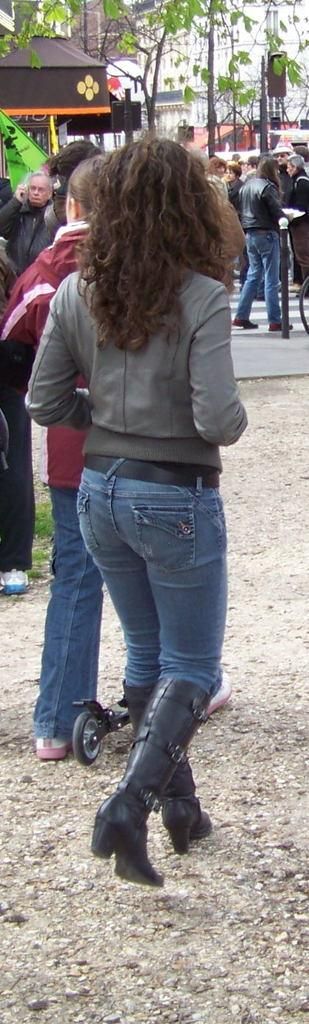Who or what can be seen in the image? There are people in the image. What type of structures are visible in the image? There are buildings in the image. What natural elements can be seen in the image? There are trees in the image. What man-made objects are present in the image? There are poles in the image. What recreational item is at the bottom of the image? There is a skateboard at the bottom of the image. What symbolic object is on the ground in the image? There is a flag on the ground in the image. What type of bone can be seen in the image? There is no bone present in the image. How many toes are visible on the people in the image? The image does not show the toes of the people, so it cannot be determined from the image. 